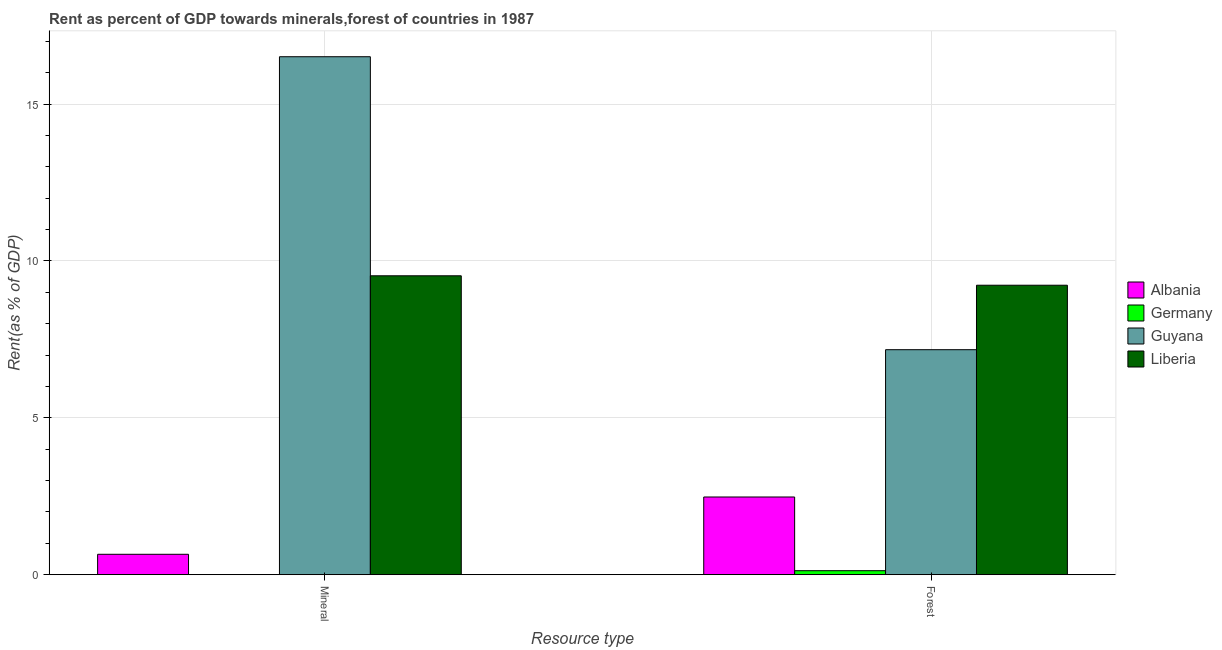How many different coloured bars are there?
Offer a terse response. 4. How many groups of bars are there?
Your response must be concise. 2. Are the number of bars per tick equal to the number of legend labels?
Provide a short and direct response. Yes. How many bars are there on the 1st tick from the left?
Your answer should be very brief. 4. What is the label of the 2nd group of bars from the left?
Your answer should be very brief. Forest. What is the forest rent in Albania?
Provide a short and direct response. 2.48. Across all countries, what is the maximum mineral rent?
Give a very brief answer. 16.51. Across all countries, what is the minimum mineral rent?
Your answer should be very brief. 0. In which country was the forest rent maximum?
Provide a succinct answer. Liberia. In which country was the mineral rent minimum?
Offer a terse response. Germany. What is the total mineral rent in the graph?
Keep it short and to the point. 26.69. What is the difference between the mineral rent in Liberia and that in Germany?
Provide a short and direct response. 9.53. What is the difference between the mineral rent in Albania and the forest rent in Germany?
Give a very brief answer. 0.52. What is the average forest rent per country?
Offer a very short reply. 4.75. What is the difference between the forest rent and mineral rent in Albania?
Give a very brief answer. 1.83. What is the ratio of the mineral rent in Liberia to that in Guyana?
Give a very brief answer. 0.58. Is the forest rent in Guyana less than that in Germany?
Your answer should be very brief. No. In how many countries, is the mineral rent greater than the average mineral rent taken over all countries?
Your answer should be compact. 2. What does the 1st bar from the left in Mineral represents?
Provide a succinct answer. Albania. What does the 2nd bar from the right in Forest represents?
Ensure brevity in your answer.  Guyana. Are all the bars in the graph horizontal?
Provide a succinct answer. No. How many countries are there in the graph?
Make the answer very short. 4. Where does the legend appear in the graph?
Offer a terse response. Center right. How many legend labels are there?
Give a very brief answer. 4. What is the title of the graph?
Provide a succinct answer. Rent as percent of GDP towards minerals,forest of countries in 1987. What is the label or title of the X-axis?
Make the answer very short. Resource type. What is the label or title of the Y-axis?
Your answer should be compact. Rent(as % of GDP). What is the Rent(as % of GDP) of Albania in Mineral?
Your answer should be compact. 0.65. What is the Rent(as % of GDP) of Germany in Mineral?
Give a very brief answer. 0. What is the Rent(as % of GDP) of Guyana in Mineral?
Your response must be concise. 16.51. What is the Rent(as % of GDP) in Liberia in Mineral?
Provide a short and direct response. 9.53. What is the Rent(as % of GDP) of Albania in Forest?
Offer a very short reply. 2.48. What is the Rent(as % of GDP) in Germany in Forest?
Your response must be concise. 0.13. What is the Rent(as % of GDP) of Guyana in Forest?
Provide a succinct answer. 7.17. What is the Rent(as % of GDP) of Liberia in Forest?
Offer a very short reply. 9.23. Across all Resource type, what is the maximum Rent(as % of GDP) of Albania?
Ensure brevity in your answer.  2.48. Across all Resource type, what is the maximum Rent(as % of GDP) of Germany?
Ensure brevity in your answer.  0.13. Across all Resource type, what is the maximum Rent(as % of GDP) in Guyana?
Your answer should be very brief. 16.51. Across all Resource type, what is the maximum Rent(as % of GDP) in Liberia?
Offer a terse response. 9.53. Across all Resource type, what is the minimum Rent(as % of GDP) of Albania?
Your answer should be very brief. 0.65. Across all Resource type, what is the minimum Rent(as % of GDP) in Germany?
Provide a short and direct response. 0. Across all Resource type, what is the minimum Rent(as % of GDP) of Guyana?
Offer a very short reply. 7.17. Across all Resource type, what is the minimum Rent(as % of GDP) of Liberia?
Your answer should be very brief. 9.23. What is the total Rent(as % of GDP) in Albania in the graph?
Make the answer very short. 3.13. What is the total Rent(as % of GDP) in Germany in the graph?
Keep it short and to the point. 0.13. What is the total Rent(as % of GDP) in Guyana in the graph?
Offer a very short reply. 23.68. What is the total Rent(as % of GDP) in Liberia in the graph?
Provide a succinct answer. 18.76. What is the difference between the Rent(as % of GDP) in Albania in Mineral and that in Forest?
Offer a terse response. -1.83. What is the difference between the Rent(as % of GDP) of Germany in Mineral and that in Forest?
Your answer should be very brief. -0.13. What is the difference between the Rent(as % of GDP) in Guyana in Mineral and that in Forest?
Offer a terse response. 9.34. What is the difference between the Rent(as % of GDP) of Liberia in Mineral and that in Forest?
Your response must be concise. 0.3. What is the difference between the Rent(as % of GDP) of Albania in Mineral and the Rent(as % of GDP) of Germany in Forest?
Your answer should be compact. 0.52. What is the difference between the Rent(as % of GDP) in Albania in Mineral and the Rent(as % of GDP) in Guyana in Forest?
Provide a short and direct response. -6.52. What is the difference between the Rent(as % of GDP) in Albania in Mineral and the Rent(as % of GDP) in Liberia in Forest?
Offer a terse response. -8.58. What is the difference between the Rent(as % of GDP) of Germany in Mineral and the Rent(as % of GDP) of Guyana in Forest?
Your answer should be very brief. -7.17. What is the difference between the Rent(as % of GDP) of Germany in Mineral and the Rent(as % of GDP) of Liberia in Forest?
Your answer should be compact. -9.23. What is the difference between the Rent(as % of GDP) in Guyana in Mineral and the Rent(as % of GDP) in Liberia in Forest?
Offer a very short reply. 7.28. What is the average Rent(as % of GDP) of Albania per Resource type?
Ensure brevity in your answer.  1.56. What is the average Rent(as % of GDP) in Germany per Resource type?
Provide a succinct answer. 0.06. What is the average Rent(as % of GDP) of Guyana per Resource type?
Your response must be concise. 11.84. What is the average Rent(as % of GDP) of Liberia per Resource type?
Give a very brief answer. 9.38. What is the difference between the Rent(as % of GDP) in Albania and Rent(as % of GDP) in Germany in Mineral?
Your response must be concise. 0.65. What is the difference between the Rent(as % of GDP) of Albania and Rent(as % of GDP) of Guyana in Mineral?
Give a very brief answer. -15.86. What is the difference between the Rent(as % of GDP) of Albania and Rent(as % of GDP) of Liberia in Mineral?
Keep it short and to the point. -8.88. What is the difference between the Rent(as % of GDP) of Germany and Rent(as % of GDP) of Guyana in Mineral?
Give a very brief answer. -16.51. What is the difference between the Rent(as % of GDP) in Germany and Rent(as % of GDP) in Liberia in Mineral?
Keep it short and to the point. -9.53. What is the difference between the Rent(as % of GDP) of Guyana and Rent(as % of GDP) of Liberia in Mineral?
Your answer should be very brief. 6.98. What is the difference between the Rent(as % of GDP) in Albania and Rent(as % of GDP) in Germany in Forest?
Keep it short and to the point. 2.35. What is the difference between the Rent(as % of GDP) in Albania and Rent(as % of GDP) in Guyana in Forest?
Keep it short and to the point. -4.7. What is the difference between the Rent(as % of GDP) of Albania and Rent(as % of GDP) of Liberia in Forest?
Your answer should be compact. -6.75. What is the difference between the Rent(as % of GDP) of Germany and Rent(as % of GDP) of Guyana in Forest?
Offer a very short reply. -7.04. What is the difference between the Rent(as % of GDP) in Guyana and Rent(as % of GDP) in Liberia in Forest?
Your response must be concise. -2.06. What is the ratio of the Rent(as % of GDP) in Albania in Mineral to that in Forest?
Provide a short and direct response. 0.26. What is the ratio of the Rent(as % of GDP) of Germany in Mineral to that in Forest?
Ensure brevity in your answer.  0. What is the ratio of the Rent(as % of GDP) of Guyana in Mineral to that in Forest?
Your answer should be very brief. 2.3. What is the ratio of the Rent(as % of GDP) in Liberia in Mineral to that in Forest?
Your answer should be compact. 1.03. What is the difference between the highest and the second highest Rent(as % of GDP) of Albania?
Provide a succinct answer. 1.83. What is the difference between the highest and the second highest Rent(as % of GDP) of Germany?
Keep it short and to the point. 0.13. What is the difference between the highest and the second highest Rent(as % of GDP) in Guyana?
Make the answer very short. 9.34. What is the difference between the highest and the second highest Rent(as % of GDP) of Liberia?
Provide a succinct answer. 0.3. What is the difference between the highest and the lowest Rent(as % of GDP) of Albania?
Ensure brevity in your answer.  1.83. What is the difference between the highest and the lowest Rent(as % of GDP) of Germany?
Offer a terse response. 0.13. What is the difference between the highest and the lowest Rent(as % of GDP) of Guyana?
Your answer should be compact. 9.34. What is the difference between the highest and the lowest Rent(as % of GDP) of Liberia?
Ensure brevity in your answer.  0.3. 